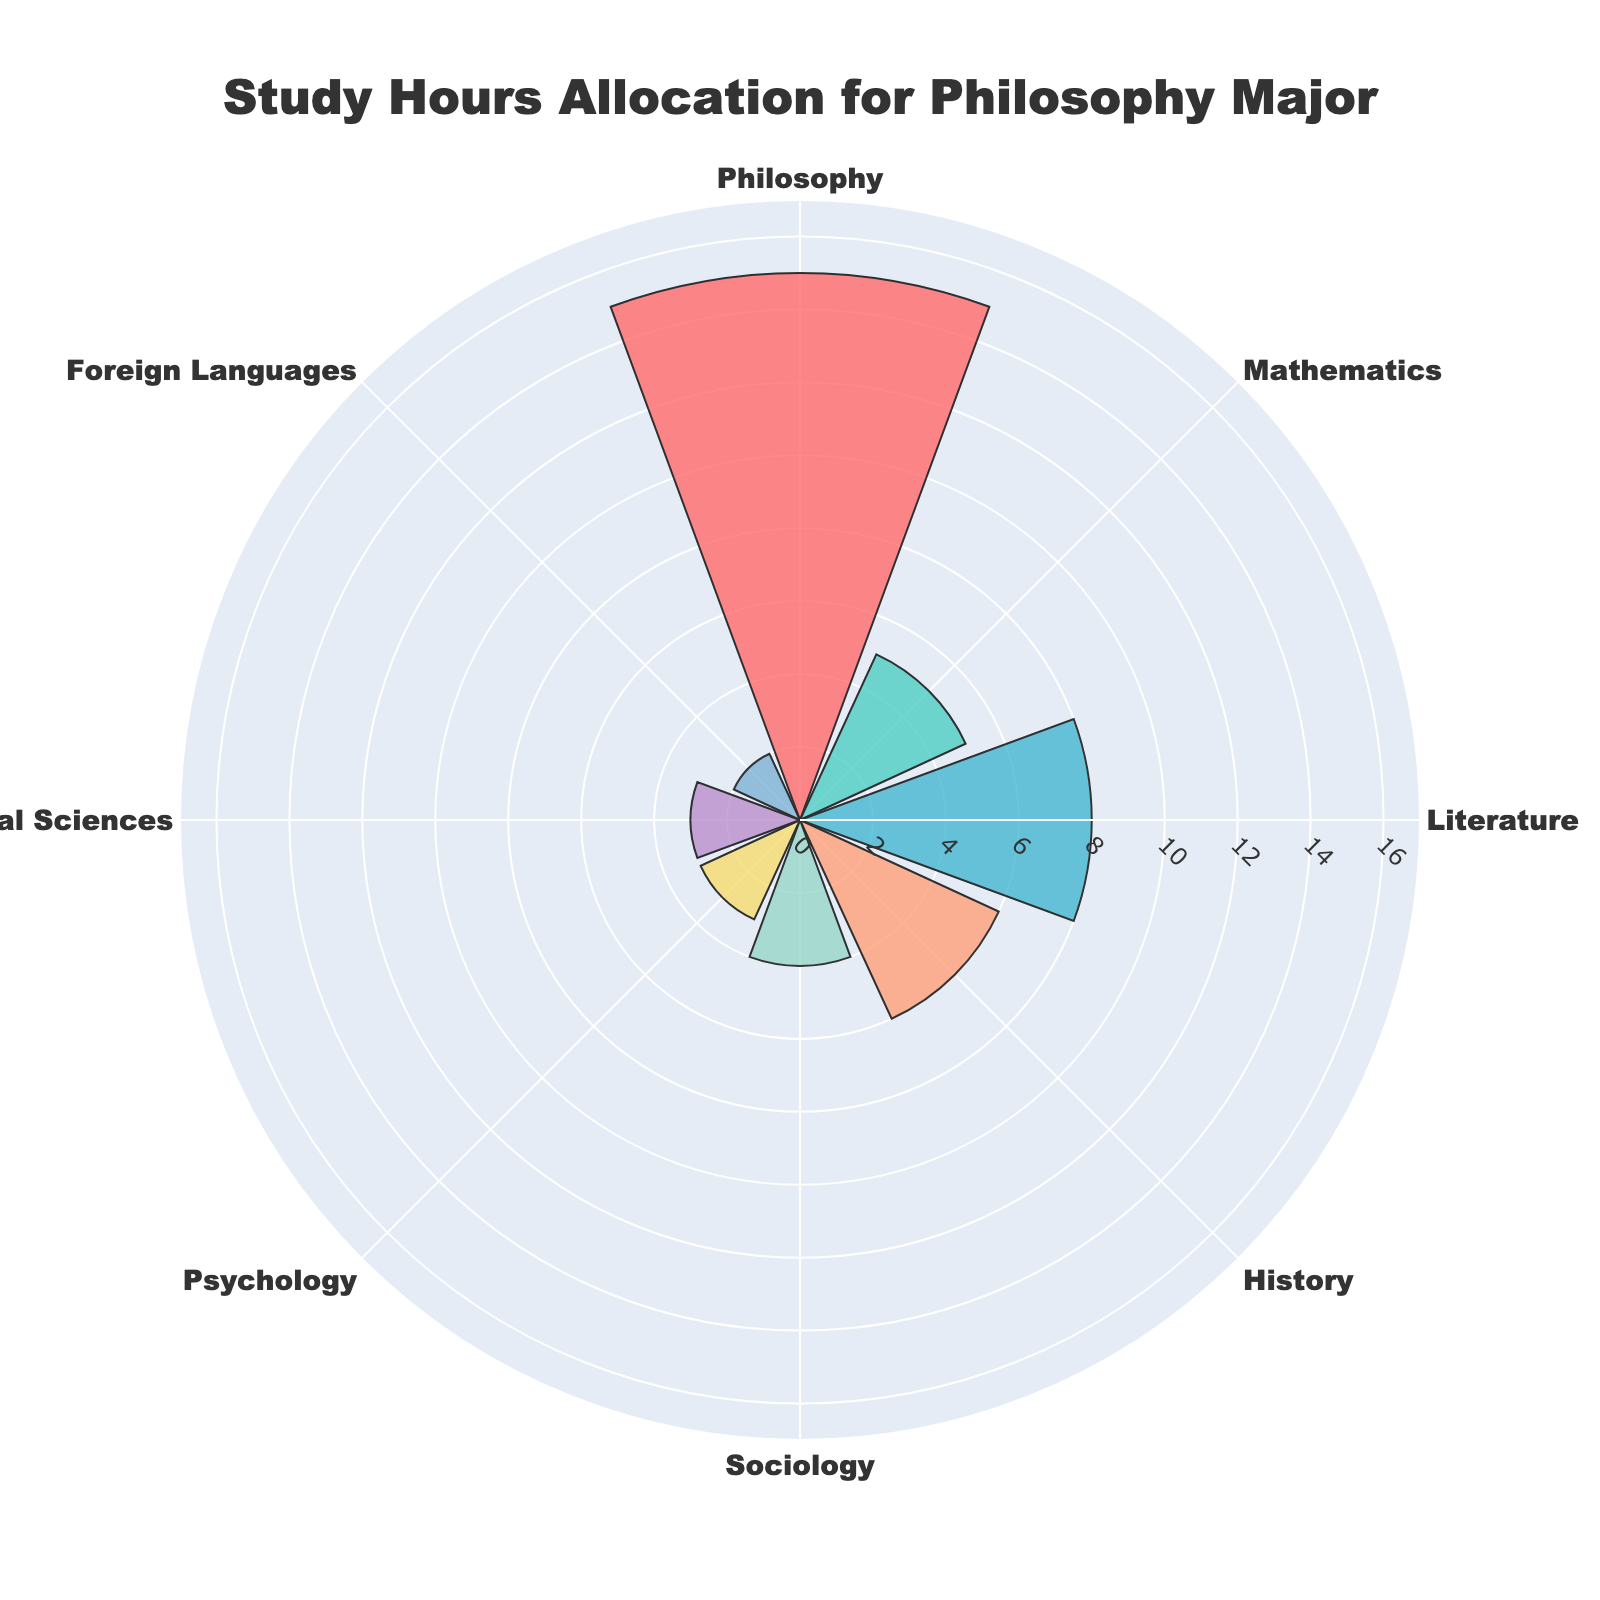What is the total number of study hours allocated per week? To find the total number of study hours, sum up the study hours for all subjects: 15 (Philosophy) + 5 (Mathematics) + 8 (Literature) + 6 (History) + 4 (Sociology) + 3 (Psychology) + 3 (Natural Sciences) + 2 (Foreign Languages) = 46 hours
Answer: 46 Which subject has the highest number of study hours allocated? Look at the polar area chart and identify the subject with the largest radial extent. Philosophy has the highest number of study hours with 15 hours
Answer: Philosophy What is the average number of study hours allocated per subject? To get the average, sum all study hours and divide by the number of subjects: 46 (total hours) / 8 (subjects) = 5.75 hours
Answer: 5.75 Which subject has the least number of study hours allocated? Identify the smallest radial extent in the polar area chart. Foreign Languages has the least number of study hours with 2 hours
Answer: Foreign Languages How do study hours for Philosophy compare to study hours for Mathematics? Philosophy study hours (15) are compared to Mathematics study hours (5). 15 is greater than 5
Answer: Philosophy has more study hours What is the combined total of study hours for Literature and Psychology? Add the study hours for Literature and Psychology: 8 (Literature) + 3 (Psychology) = 11 hours
Answer: 11 How many subjects have more than 5 study hours allocated per week? Identify subjects with study hours greater than 5: Philosophy (15), Literature (8), History (6). There are 3 subjects
Answer: 3 What's the difference in study hours between Sociology and Natural Sciences? Subtract the study hours of Natural Sciences from Sociology: 4 (Sociology) - 3 (Natural Sciences) = 1 hour
Answer: 1 What proportion of total study hours are dedicated to Philosophy? Divide the study hours of Philosophy by the total study hours and multiply by 100 to get the percentage: (15 / 46) * 100 ≈ 32.61%
Answer: ~32.61% Which subjects have study hours below the average weekly study hours? Average weekly study hours is 5.75. Identify subjects with study hours below 5.75: Mathematics (5), Sociology (4), Psychology (3), Natural Sciences (3), Foreign Languages (2)
Answer: Mathematics, Sociology, Psychology, Natural Sciences, Foreign Languages 